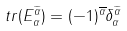<formula> <loc_0><loc_0><loc_500><loc_500>t r ( E _ { \alpha } ^ { \widetilde { \alpha } } ) = ( - 1 ) ^ { \overline { \alpha } } \delta _ { \alpha } ^ { \widetilde { \alpha } }</formula> 